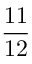<formula> <loc_0><loc_0><loc_500><loc_500>\frac { 1 1 } { 1 2 }</formula> 